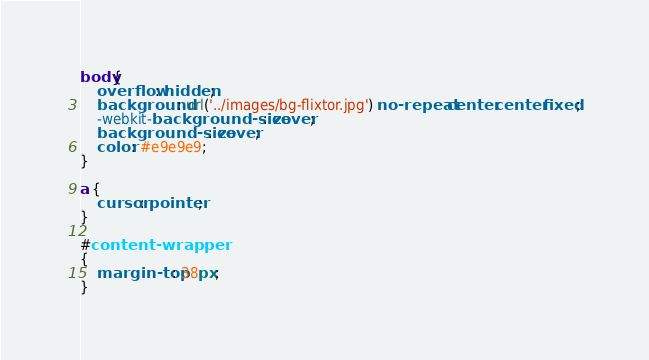Convert code to text. <code><loc_0><loc_0><loc_500><loc_500><_CSS_>body{
    overflow: hidden;
    background: url('../images/bg-flixtor.jpg') no-repeat center center fixed;
    -webkit-background-size: cover;
    background-size: cover;
    color: #e9e9e9;
}

a {
    cursor: pointer;
}

#content-wrapper
{
    margin-top: 38px;
}
</code> 